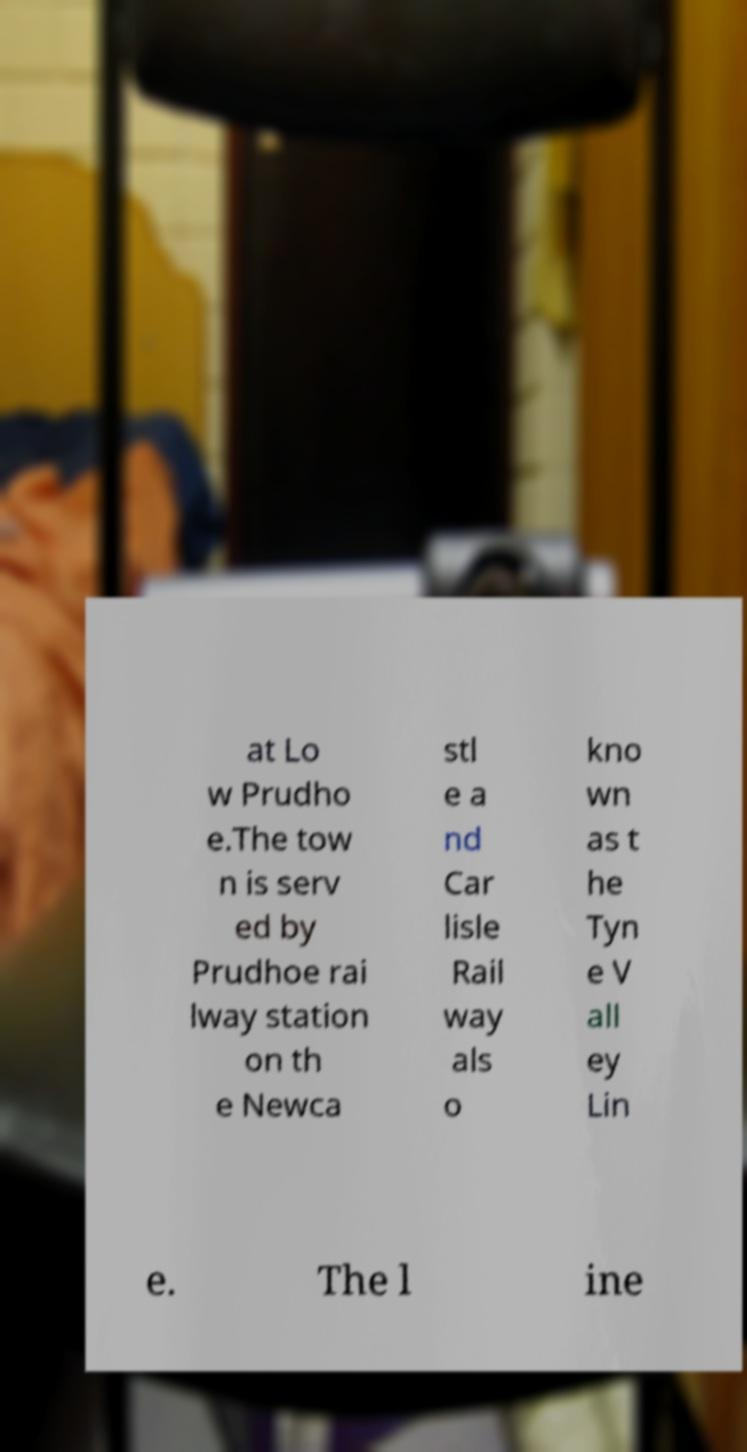I need the written content from this picture converted into text. Can you do that? at Lo w Prudho e.The tow n is serv ed by Prudhoe rai lway station on th e Newca stl e a nd Car lisle Rail way als o kno wn as t he Tyn e V all ey Lin e. The l ine 